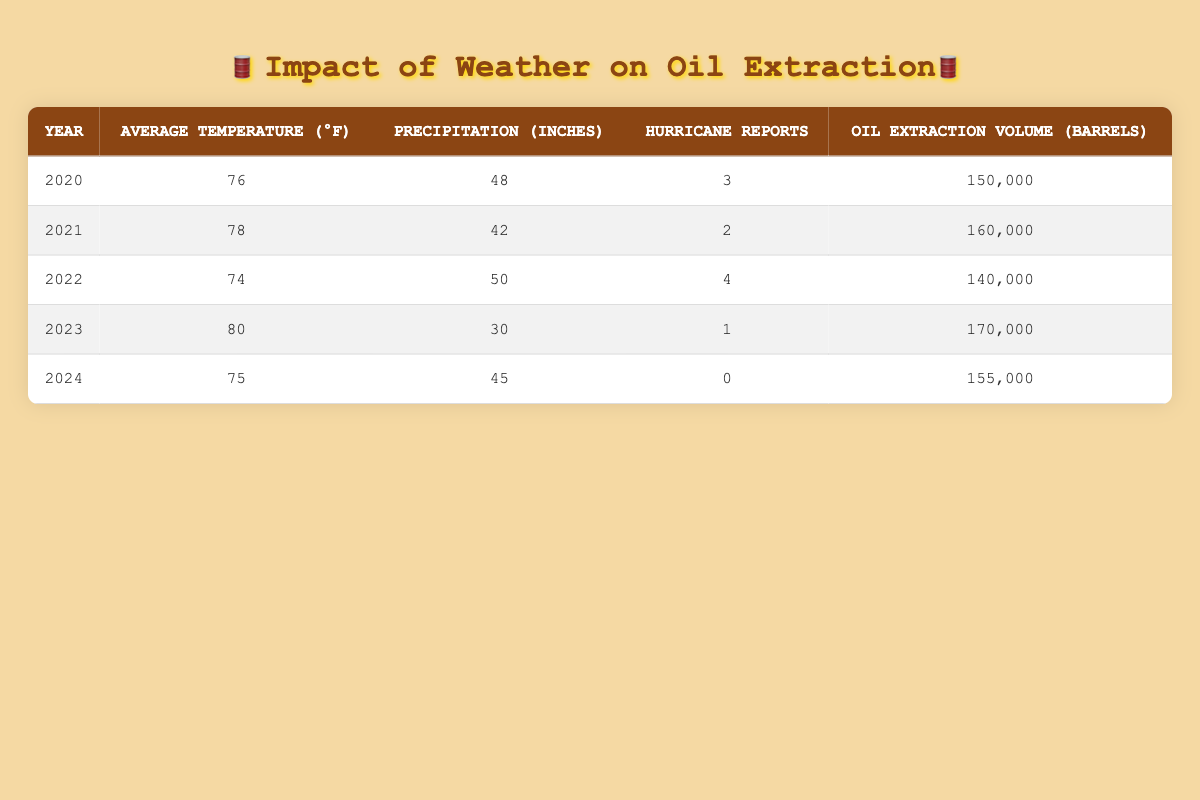What year had the highest oil extraction volume? Looking at the "Oil Extraction Volume" column, 2023 shows the highest value at 170,000 barrels.
Answer: 2023 What is the average temperature in 2021? Referring to the table, the average temperature listed for 2021 is 78°F.
Answer: 78°F Is there a correlation between the number of hurricane reports and oil extraction volume? Observing the years with hurricane reports and their corresponding extraction volumes: 2020 (3 hurricanes, 150,000 barrels), 2021 (2 hurricanes, 160,000 barrels), 2022 (4 hurricanes, 140,000 barrels), 2023 (1 hurricane, 170,000 barrels). There is no consistent trend, as fewer hurricanes did not always correlate with higher extraction volume.
Answer: No What was the total precipitation from 2020 to 2024? Adding the precipitation values: 48 + 42 + 50 + 30 + 45 = 215 inches of precipitation total from 2020 to 2024.
Answer: 215 inches In which year did an increase in temperature coincide with an increase in oil extraction volume? Evaluating the years: from 2020 (76°F, 150,000 barrels) to 2021 (78°F, 160,000 barrels), there is a clear increase in both factors.
Answer: 2021 What year had the lowest oil extraction volume? Searching through the table, the lowest oil extraction volume was 140,000 barrels in 2022.
Answer: 2022 How many total hurricane reports were there from 2020 to 2024? Summing the hurricane reports: 3 + 2 + 4 + 1 + 0 = 10 hurricane reports total over the five years.
Answer: 10 reports What was the average oil extraction volume over the years 2020 to 2024? To find the average, sum the barrels: 150,000 + 160,000 + 140,000 + 170,000 + 155,000 = 775,000, then divide by 5 (the number of years), resulting in 775,000 / 5 = 155,000 barrels on average.
Answer: 155,000 barrels Did precipitation affect oil extraction volume positively or negatively in the given years? Analyzing the data: In 2020 (48 inches, 150,000 barrels), 2021 (42 inches, 160,000 barrels), 2022 (50 inches, 140,000 barrels), 2023 (30 inches, 170,000 barrels), and 2024 (45 inches, 155,000 barrels). The trend doesn't show a clear positive correlation, as higher precipitation did not consistently lead to higher extraction volumes.
Answer: No clear effect 